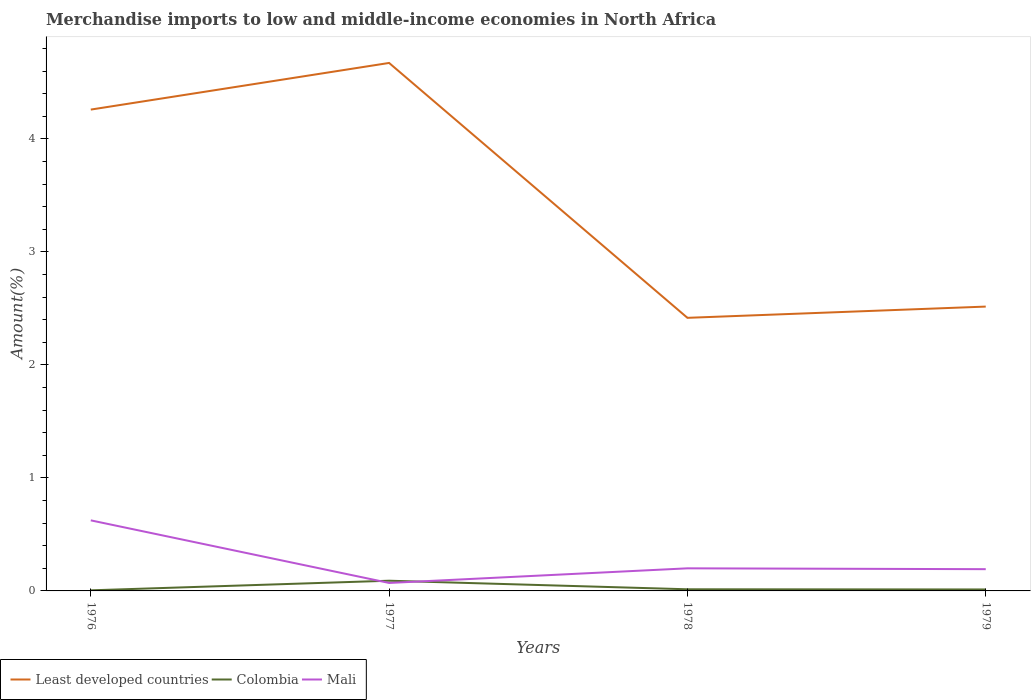How many different coloured lines are there?
Make the answer very short. 3. Is the number of lines equal to the number of legend labels?
Keep it short and to the point. Yes. Across all years, what is the maximum percentage of amount earned from merchandise imports in Colombia?
Give a very brief answer. 0.01. In which year was the percentage of amount earned from merchandise imports in Least developed countries maximum?
Your answer should be very brief. 1978. What is the total percentage of amount earned from merchandise imports in Mali in the graph?
Give a very brief answer. -0.13. What is the difference between the highest and the second highest percentage of amount earned from merchandise imports in Mali?
Make the answer very short. 0.55. What is the difference between the highest and the lowest percentage of amount earned from merchandise imports in Mali?
Give a very brief answer. 1. Is the percentage of amount earned from merchandise imports in Least developed countries strictly greater than the percentage of amount earned from merchandise imports in Mali over the years?
Provide a short and direct response. No. What is the difference between two consecutive major ticks on the Y-axis?
Your answer should be compact. 1. Are the values on the major ticks of Y-axis written in scientific E-notation?
Keep it short and to the point. No. Does the graph contain grids?
Offer a terse response. No. Where does the legend appear in the graph?
Ensure brevity in your answer.  Bottom left. How many legend labels are there?
Provide a short and direct response. 3. How are the legend labels stacked?
Provide a succinct answer. Horizontal. What is the title of the graph?
Keep it short and to the point. Merchandise imports to low and middle-income economies in North Africa. What is the label or title of the X-axis?
Ensure brevity in your answer.  Years. What is the label or title of the Y-axis?
Provide a short and direct response. Amount(%). What is the Amount(%) in Least developed countries in 1976?
Your answer should be very brief. 4.26. What is the Amount(%) of Colombia in 1976?
Your answer should be very brief. 0.01. What is the Amount(%) of Mali in 1976?
Offer a very short reply. 0.62. What is the Amount(%) of Least developed countries in 1977?
Your answer should be compact. 4.67. What is the Amount(%) of Colombia in 1977?
Give a very brief answer. 0.09. What is the Amount(%) in Mali in 1977?
Your answer should be very brief. 0.07. What is the Amount(%) of Least developed countries in 1978?
Your answer should be very brief. 2.42. What is the Amount(%) of Colombia in 1978?
Your answer should be compact. 0.01. What is the Amount(%) in Mali in 1978?
Keep it short and to the point. 0.2. What is the Amount(%) in Least developed countries in 1979?
Your answer should be compact. 2.52. What is the Amount(%) of Colombia in 1979?
Provide a short and direct response. 0.01. What is the Amount(%) of Mali in 1979?
Your answer should be very brief. 0.19. Across all years, what is the maximum Amount(%) of Least developed countries?
Give a very brief answer. 4.67. Across all years, what is the maximum Amount(%) of Colombia?
Give a very brief answer. 0.09. Across all years, what is the maximum Amount(%) in Mali?
Make the answer very short. 0.62. Across all years, what is the minimum Amount(%) in Least developed countries?
Offer a terse response. 2.42. Across all years, what is the minimum Amount(%) of Colombia?
Offer a terse response. 0.01. Across all years, what is the minimum Amount(%) of Mali?
Your response must be concise. 0.07. What is the total Amount(%) in Least developed countries in the graph?
Your response must be concise. 13.87. What is the total Amount(%) in Colombia in the graph?
Provide a succinct answer. 0.12. What is the total Amount(%) of Mali in the graph?
Ensure brevity in your answer.  1.09. What is the difference between the Amount(%) in Least developed countries in 1976 and that in 1977?
Your answer should be very brief. -0.41. What is the difference between the Amount(%) of Colombia in 1976 and that in 1977?
Your answer should be compact. -0.09. What is the difference between the Amount(%) of Mali in 1976 and that in 1977?
Provide a short and direct response. 0.55. What is the difference between the Amount(%) of Least developed countries in 1976 and that in 1978?
Your answer should be compact. 1.84. What is the difference between the Amount(%) of Colombia in 1976 and that in 1978?
Offer a terse response. -0.01. What is the difference between the Amount(%) in Mali in 1976 and that in 1978?
Offer a terse response. 0.42. What is the difference between the Amount(%) of Least developed countries in 1976 and that in 1979?
Give a very brief answer. 1.74. What is the difference between the Amount(%) of Colombia in 1976 and that in 1979?
Make the answer very short. -0.01. What is the difference between the Amount(%) in Mali in 1976 and that in 1979?
Offer a terse response. 0.43. What is the difference between the Amount(%) in Least developed countries in 1977 and that in 1978?
Keep it short and to the point. 2.26. What is the difference between the Amount(%) in Colombia in 1977 and that in 1978?
Give a very brief answer. 0.08. What is the difference between the Amount(%) of Mali in 1977 and that in 1978?
Provide a short and direct response. -0.13. What is the difference between the Amount(%) in Least developed countries in 1977 and that in 1979?
Offer a very short reply. 2.16. What is the difference between the Amount(%) of Colombia in 1977 and that in 1979?
Provide a short and direct response. 0.08. What is the difference between the Amount(%) of Mali in 1977 and that in 1979?
Ensure brevity in your answer.  -0.12. What is the difference between the Amount(%) in Least developed countries in 1978 and that in 1979?
Give a very brief answer. -0.1. What is the difference between the Amount(%) of Colombia in 1978 and that in 1979?
Ensure brevity in your answer.  0. What is the difference between the Amount(%) in Mali in 1978 and that in 1979?
Make the answer very short. 0.01. What is the difference between the Amount(%) in Least developed countries in 1976 and the Amount(%) in Colombia in 1977?
Your answer should be compact. 4.17. What is the difference between the Amount(%) in Least developed countries in 1976 and the Amount(%) in Mali in 1977?
Give a very brief answer. 4.19. What is the difference between the Amount(%) of Colombia in 1976 and the Amount(%) of Mali in 1977?
Your response must be concise. -0.07. What is the difference between the Amount(%) of Least developed countries in 1976 and the Amount(%) of Colombia in 1978?
Make the answer very short. 4.25. What is the difference between the Amount(%) of Least developed countries in 1976 and the Amount(%) of Mali in 1978?
Give a very brief answer. 4.06. What is the difference between the Amount(%) in Colombia in 1976 and the Amount(%) in Mali in 1978?
Offer a very short reply. -0.19. What is the difference between the Amount(%) of Least developed countries in 1976 and the Amount(%) of Colombia in 1979?
Provide a succinct answer. 4.25. What is the difference between the Amount(%) in Least developed countries in 1976 and the Amount(%) in Mali in 1979?
Keep it short and to the point. 4.07. What is the difference between the Amount(%) of Colombia in 1976 and the Amount(%) of Mali in 1979?
Provide a short and direct response. -0.19. What is the difference between the Amount(%) in Least developed countries in 1977 and the Amount(%) in Colombia in 1978?
Offer a terse response. 4.66. What is the difference between the Amount(%) of Least developed countries in 1977 and the Amount(%) of Mali in 1978?
Your response must be concise. 4.47. What is the difference between the Amount(%) of Colombia in 1977 and the Amount(%) of Mali in 1978?
Offer a very short reply. -0.11. What is the difference between the Amount(%) in Least developed countries in 1977 and the Amount(%) in Colombia in 1979?
Offer a terse response. 4.66. What is the difference between the Amount(%) in Least developed countries in 1977 and the Amount(%) in Mali in 1979?
Ensure brevity in your answer.  4.48. What is the difference between the Amount(%) in Colombia in 1977 and the Amount(%) in Mali in 1979?
Provide a short and direct response. -0.1. What is the difference between the Amount(%) of Least developed countries in 1978 and the Amount(%) of Colombia in 1979?
Offer a terse response. 2.4. What is the difference between the Amount(%) of Least developed countries in 1978 and the Amount(%) of Mali in 1979?
Offer a terse response. 2.22. What is the difference between the Amount(%) in Colombia in 1978 and the Amount(%) in Mali in 1979?
Offer a very short reply. -0.18. What is the average Amount(%) in Least developed countries per year?
Provide a succinct answer. 3.47. What is the average Amount(%) in Colombia per year?
Your answer should be compact. 0.03. What is the average Amount(%) in Mali per year?
Your answer should be compact. 0.27. In the year 1976, what is the difference between the Amount(%) of Least developed countries and Amount(%) of Colombia?
Make the answer very short. 4.25. In the year 1976, what is the difference between the Amount(%) of Least developed countries and Amount(%) of Mali?
Make the answer very short. 3.64. In the year 1976, what is the difference between the Amount(%) in Colombia and Amount(%) in Mali?
Offer a terse response. -0.62. In the year 1977, what is the difference between the Amount(%) of Least developed countries and Amount(%) of Colombia?
Make the answer very short. 4.58. In the year 1977, what is the difference between the Amount(%) of Least developed countries and Amount(%) of Mali?
Give a very brief answer. 4.6. In the year 1977, what is the difference between the Amount(%) in Colombia and Amount(%) in Mali?
Make the answer very short. 0.02. In the year 1978, what is the difference between the Amount(%) of Least developed countries and Amount(%) of Colombia?
Offer a terse response. 2.4. In the year 1978, what is the difference between the Amount(%) in Least developed countries and Amount(%) in Mali?
Keep it short and to the point. 2.22. In the year 1978, what is the difference between the Amount(%) of Colombia and Amount(%) of Mali?
Give a very brief answer. -0.19. In the year 1979, what is the difference between the Amount(%) in Least developed countries and Amount(%) in Colombia?
Your answer should be very brief. 2.5. In the year 1979, what is the difference between the Amount(%) in Least developed countries and Amount(%) in Mali?
Your answer should be very brief. 2.32. In the year 1979, what is the difference between the Amount(%) of Colombia and Amount(%) of Mali?
Provide a succinct answer. -0.18. What is the ratio of the Amount(%) of Least developed countries in 1976 to that in 1977?
Provide a succinct answer. 0.91. What is the ratio of the Amount(%) in Colombia in 1976 to that in 1977?
Provide a short and direct response. 0.06. What is the ratio of the Amount(%) in Mali in 1976 to that in 1977?
Your response must be concise. 8.85. What is the ratio of the Amount(%) in Least developed countries in 1976 to that in 1978?
Offer a very short reply. 1.76. What is the ratio of the Amount(%) in Colombia in 1976 to that in 1978?
Your answer should be compact. 0.36. What is the ratio of the Amount(%) of Mali in 1976 to that in 1978?
Your answer should be very brief. 3.12. What is the ratio of the Amount(%) of Least developed countries in 1976 to that in 1979?
Ensure brevity in your answer.  1.69. What is the ratio of the Amount(%) of Colombia in 1976 to that in 1979?
Keep it short and to the point. 0.41. What is the ratio of the Amount(%) in Mali in 1976 to that in 1979?
Keep it short and to the point. 3.24. What is the ratio of the Amount(%) of Least developed countries in 1977 to that in 1978?
Provide a short and direct response. 1.93. What is the ratio of the Amount(%) in Colombia in 1977 to that in 1978?
Ensure brevity in your answer.  6.24. What is the ratio of the Amount(%) in Mali in 1977 to that in 1978?
Ensure brevity in your answer.  0.35. What is the ratio of the Amount(%) in Least developed countries in 1977 to that in 1979?
Your answer should be compact. 1.86. What is the ratio of the Amount(%) in Colombia in 1977 to that in 1979?
Offer a very short reply. 6.95. What is the ratio of the Amount(%) in Mali in 1977 to that in 1979?
Provide a succinct answer. 0.37. What is the ratio of the Amount(%) of Least developed countries in 1978 to that in 1979?
Ensure brevity in your answer.  0.96. What is the ratio of the Amount(%) of Colombia in 1978 to that in 1979?
Provide a succinct answer. 1.11. What is the ratio of the Amount(%) in Mali in 1978 to that in 1979?
Provide a succinct answer. 1.04. What is the difference between the highest and the second highest Amount(%) of Least developed countries?
Offer a terse response. 0.41. What is the difference between the highest and the second highest Amount(%) of Colombia?
Your response must be concise. 0.08. What is the difference between the highest and the second highest Amount(%) of Mali?
Provide a succinct answer. 0.42. What is the difference between the highest and the lowest Amount(%) of Least developed countries?
Your response must be concise. 2.26. What is the difference between the highest and the lowest Amount(%) in Colombia?
Your answer should be compact. 0.09. What is the difference between the highest and the lowest Amount(%) in Mali?
Offer a terse response. 0.55. 